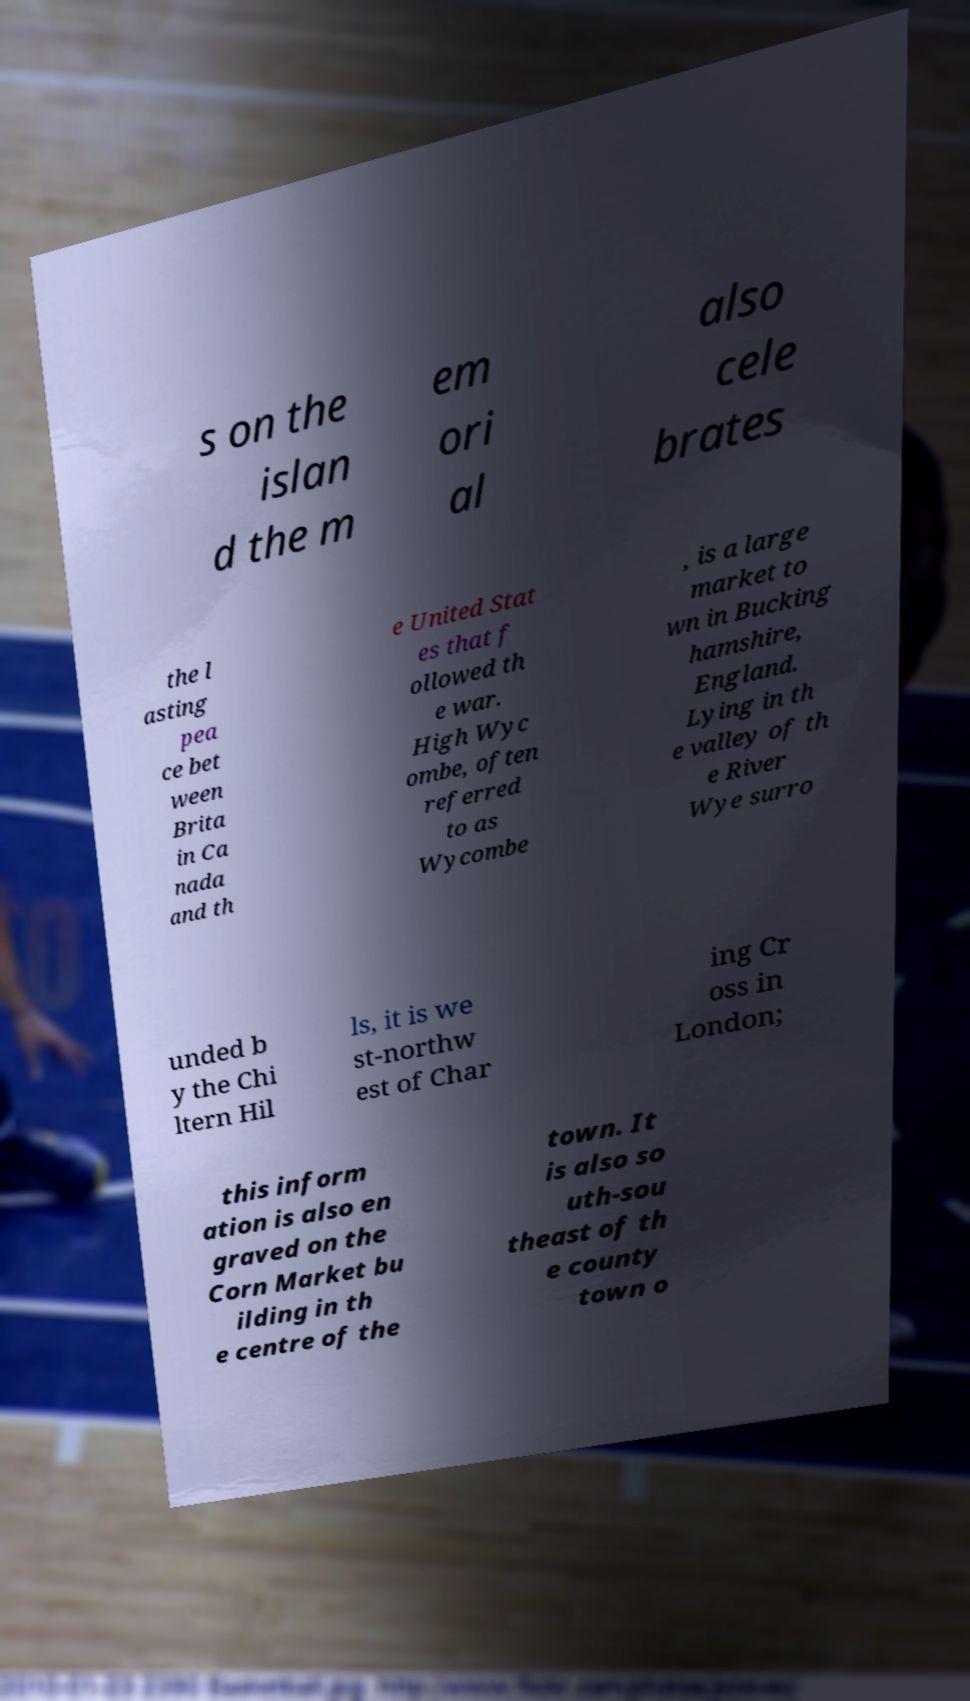Can you accurately transcribe the text from the provided image for me? s on the islan d the m em ori al also cele brates the l asting pea ce bet ween Brita in Ca nada and th e United Stat es that f ollowed th e war. High Wyc ombe, often referred to as Wycombe , is a large market to wn in Bucking hamshire, England. Lying in th e valley of th e River Wye surro unded b y the Chi ltern Hil ls, it is we st-northw est of Char ing Cr oss in London; this inform ation is also en graved on the Corn Market bu ilding in th e centre of the town. It is also so uth-sou theast of th e county town o 